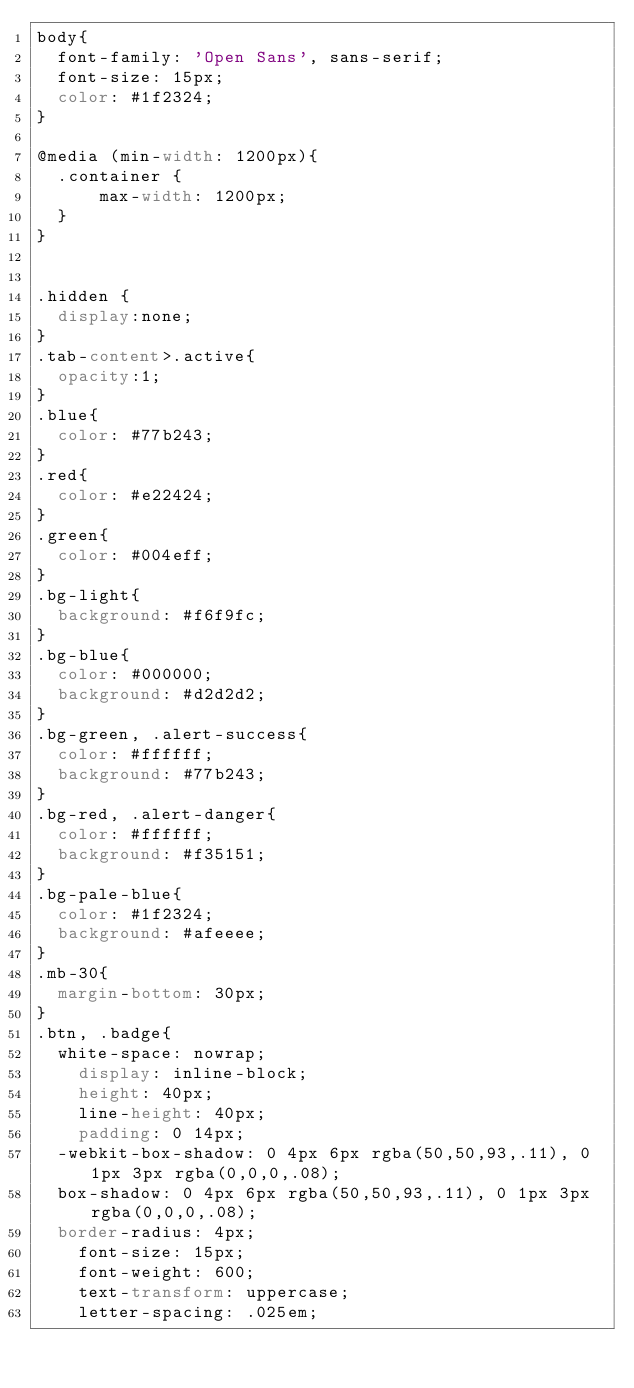<code> <loc_0><loc_0><loc_500><loc_500><_CSS_>body{
  font-family: 'Open Sans', sans-serif;
  font-size: 15px;
  color: #1f2324;
}

@media (min-width: 1200px){
  .container {
      max-width: 1200px;
  }
}


.hidden {
  display:none;
}
.tab-content>.active{
  opacity:1;  
}
.blue{
  color: #77b243;
}
.red{
  color: #e22424;
}
.green{
  color: #004eff;
}
.bg-light{
  background: #f6f9fc;
}
.bg-blue{
  color: #000000;
  background: #d2d2d2;
}
.bg-green, .alert-success{
  color: #ffffff;
  background: #77b243;
}
.bg-red, .alert-danger{
  color: #ffffff;
  background: #f35151;
}
.bg-pale-blue{
  color: #1f2324;
  background: #afeeee;
}
.mb-30{
  margin-bottom: 30px;
}
.btn, .badge{
  white-space: nowrap;
    display: inline-block;
    height: 40px;
    line-height: 40px;
    padding: 0 14px;
  -webkit-box-shadow: 0 4px 6px rgba(50,50,93,.11), 0 1px 3px rgba(0,0,0,.08);
  box-shadow: 0 4px 6px rgba(50,50,93,.11), 0 1px 3px rgba(0,0,0,.08);
  border-radius: 4px;
    font-size: 15px;
    font-weight: 600;
    text-transform: uppercase;
    letter-spacing: .025em;</code> 